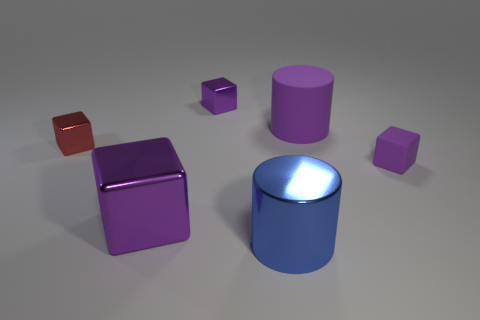Does the small red object have the same shape as the purple metal object behind the small matte cube?
Make the answer very short. Yes. How many metallic objects are either tiny purple blocks or large things?
Offer a very short reply. 3. The shiny object on the right side of the purple cube behind the large cylinder behind the blue metallic thing is what color?
Offer a terse response. Blue. How many other things are there of the same material as the red cube?
Ensure brevity in your answer.  3. There is a big purple object on the right side of the big purple shiny object; is its shape the same as the small red metallic thing?
Offer a very short reply. No. What number of small objects are blue matte things or shiny things?
Your answer should be very brief. 2. Are there an equal number of purple rubber things that are behind the small purple shiny object and small red metal objects that are in front of the big purple metallic object?
Offer a very short reply. Yes. How many other objects are there of the same color as the big metal cube?
Your answer should be very brief. 3. Do the matte cylinder and the large thing left of the large blue metallic object have the same color?
Your answer should be compact. Yes. What number of blue objects are big cylinders or cubes?
Your answer should be compact. 1. 